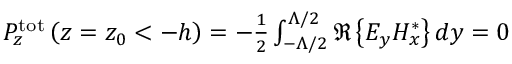<formula> <loc_0><loc_0><loc_500><loc_500>\begin{array} { r } { P _ { z } ^ { t o t } \left ( z = z _ { 0 } < - h \right ) = - \frac { 1 } { 2 } \int _ { - \Lambda / 2 } ^ { \Lambda / 2 } \Re \left \{ E _ { y } H _ { x } ^ { * } \right \} d y = 0 } \end{array}</formula> 